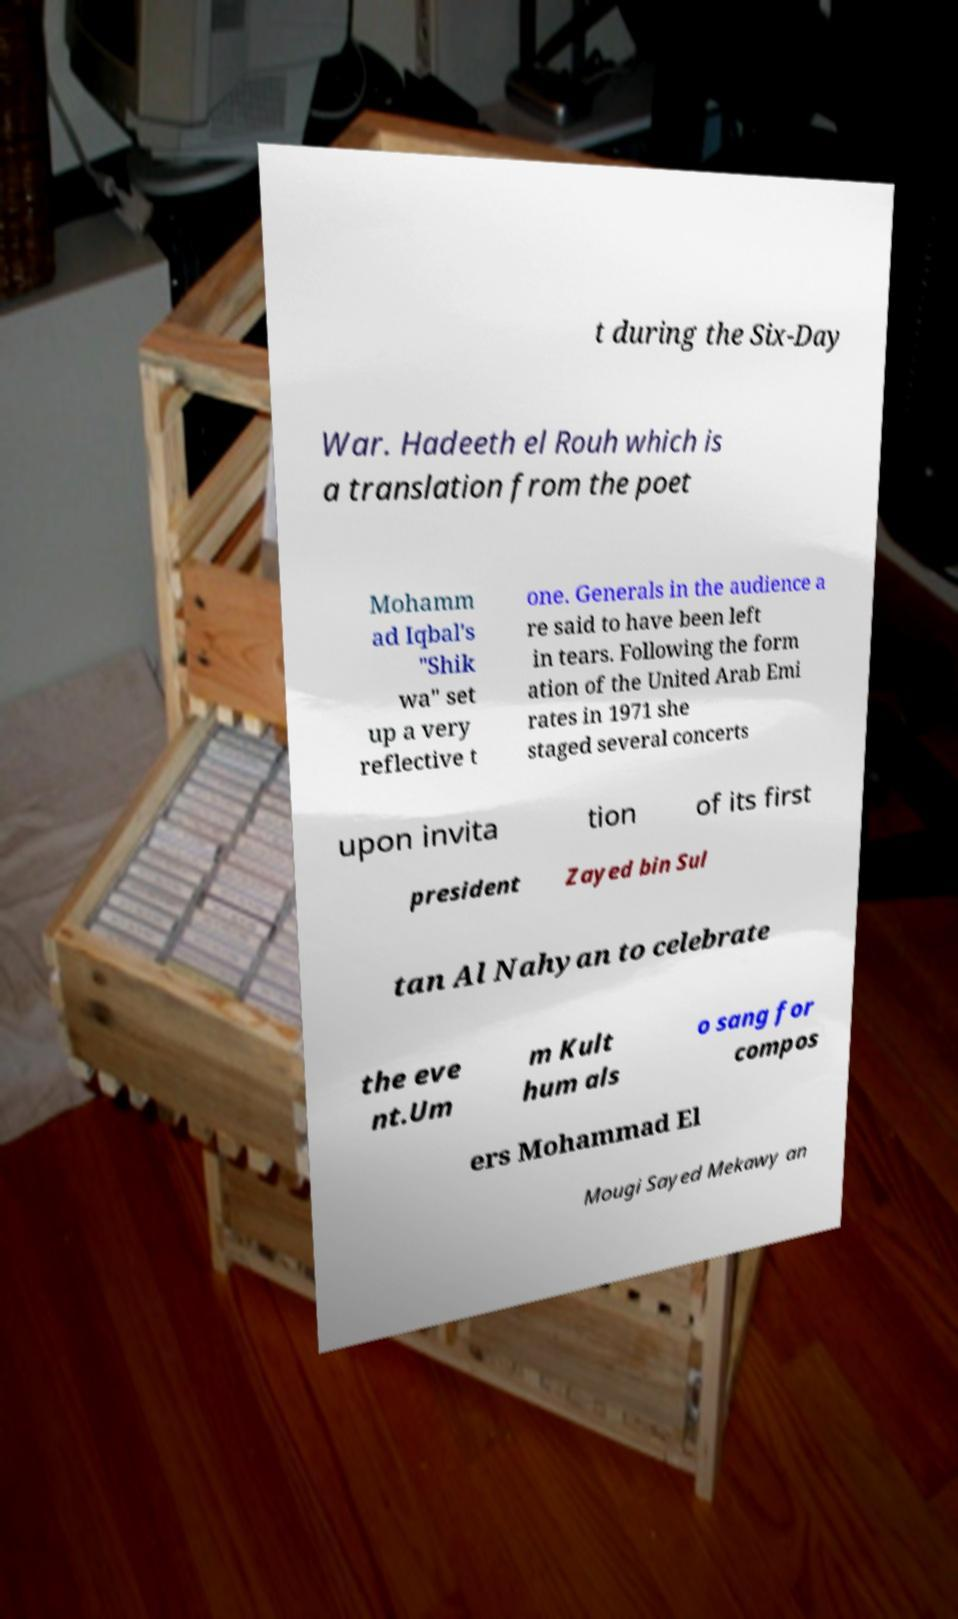What messages or text are displayed in this image? I need them in a readable, typed format. t during the Six-Day War. Hadeeth el Rouh which is a translation from the poet Mohamm ad Iqbal's "Shik wa" set up a very reflective t one. Generals in the audience a re said to have been left in tears. Following the form ation of the United Arab Emi rates in 1971 she staged several concerts upon invita tion of its first president Zayed bin Sul tan Al Nahyan to celebrate the eve nt.Um m Kult hum als o sang for compos ers Mohammad El Mougi Sayed Mekawy an 